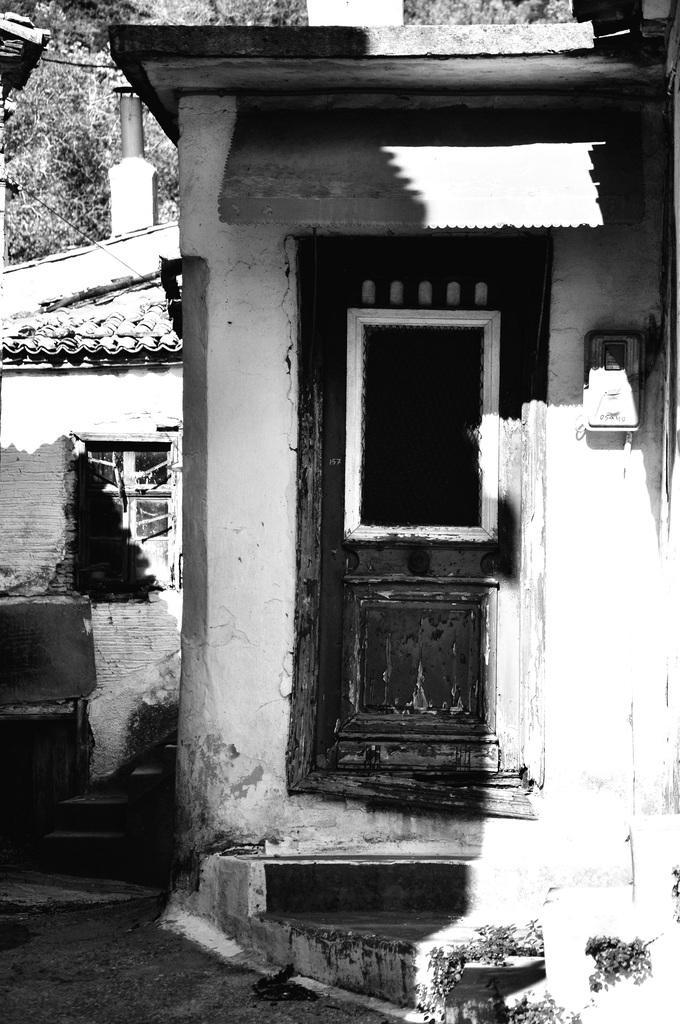Can you describe this image briefly? In this picture there is a small house in the center of the image and there is another house on the left side of the image and there are trees at the top side of the image. 